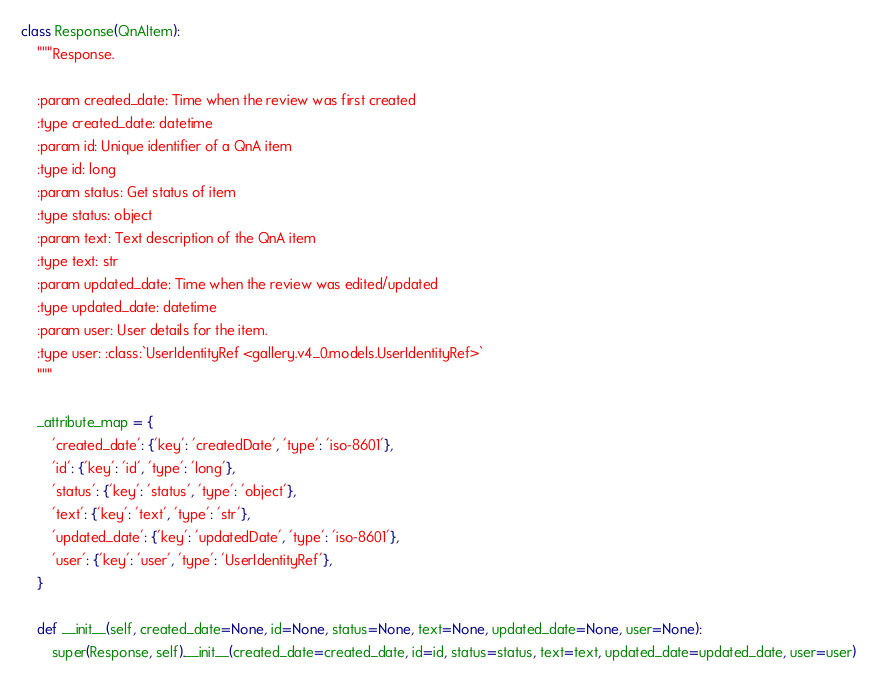Convert code to text. <code><loc_0><loc_0><loc_500><loc_500><_Python_>

class Response(QnAItem):
    """Response.

    :param created_date: Time when the review was first created
    :type created_date: datetime
    :param id: Unique identifier of a QnA item
    :type id: long
    :param status: Get status of item
    :type status: object
    :param text: Text description of the QnA item
    :type text: str
    :param updated_date: Time when the review was edited/updated
    :type updated_date: datetime
    :param user: User details for the item.
    :type user: :class:`UserIdentityRef <gallery.v4_0.models.UserIdentityRef>`
    """

    _attribute_map = {
        'created_date': {'key': 'createdDate', 'type': 'iso-8601'},
        'id': {'key': 'id', 'type': 'long'},
        'status': {'key': 'status', 'type': 'object'},
        'text': {'key': 'text', 'type': 'str'},
        'updated_date': {'key': 'updatedDate', 'type': 'iso-8601'},
        'user': {'key': 'user', 'type': 'UserIdentityRef'},
    }

    def __init__(self, created_date=None, id=None, status=None, text=None, updated_date=None, user=None):
        super(Response, self).__init__(created_date=created_date, id=id, status=status, text=text, updated_date=updated_date, user=user)
</code> 